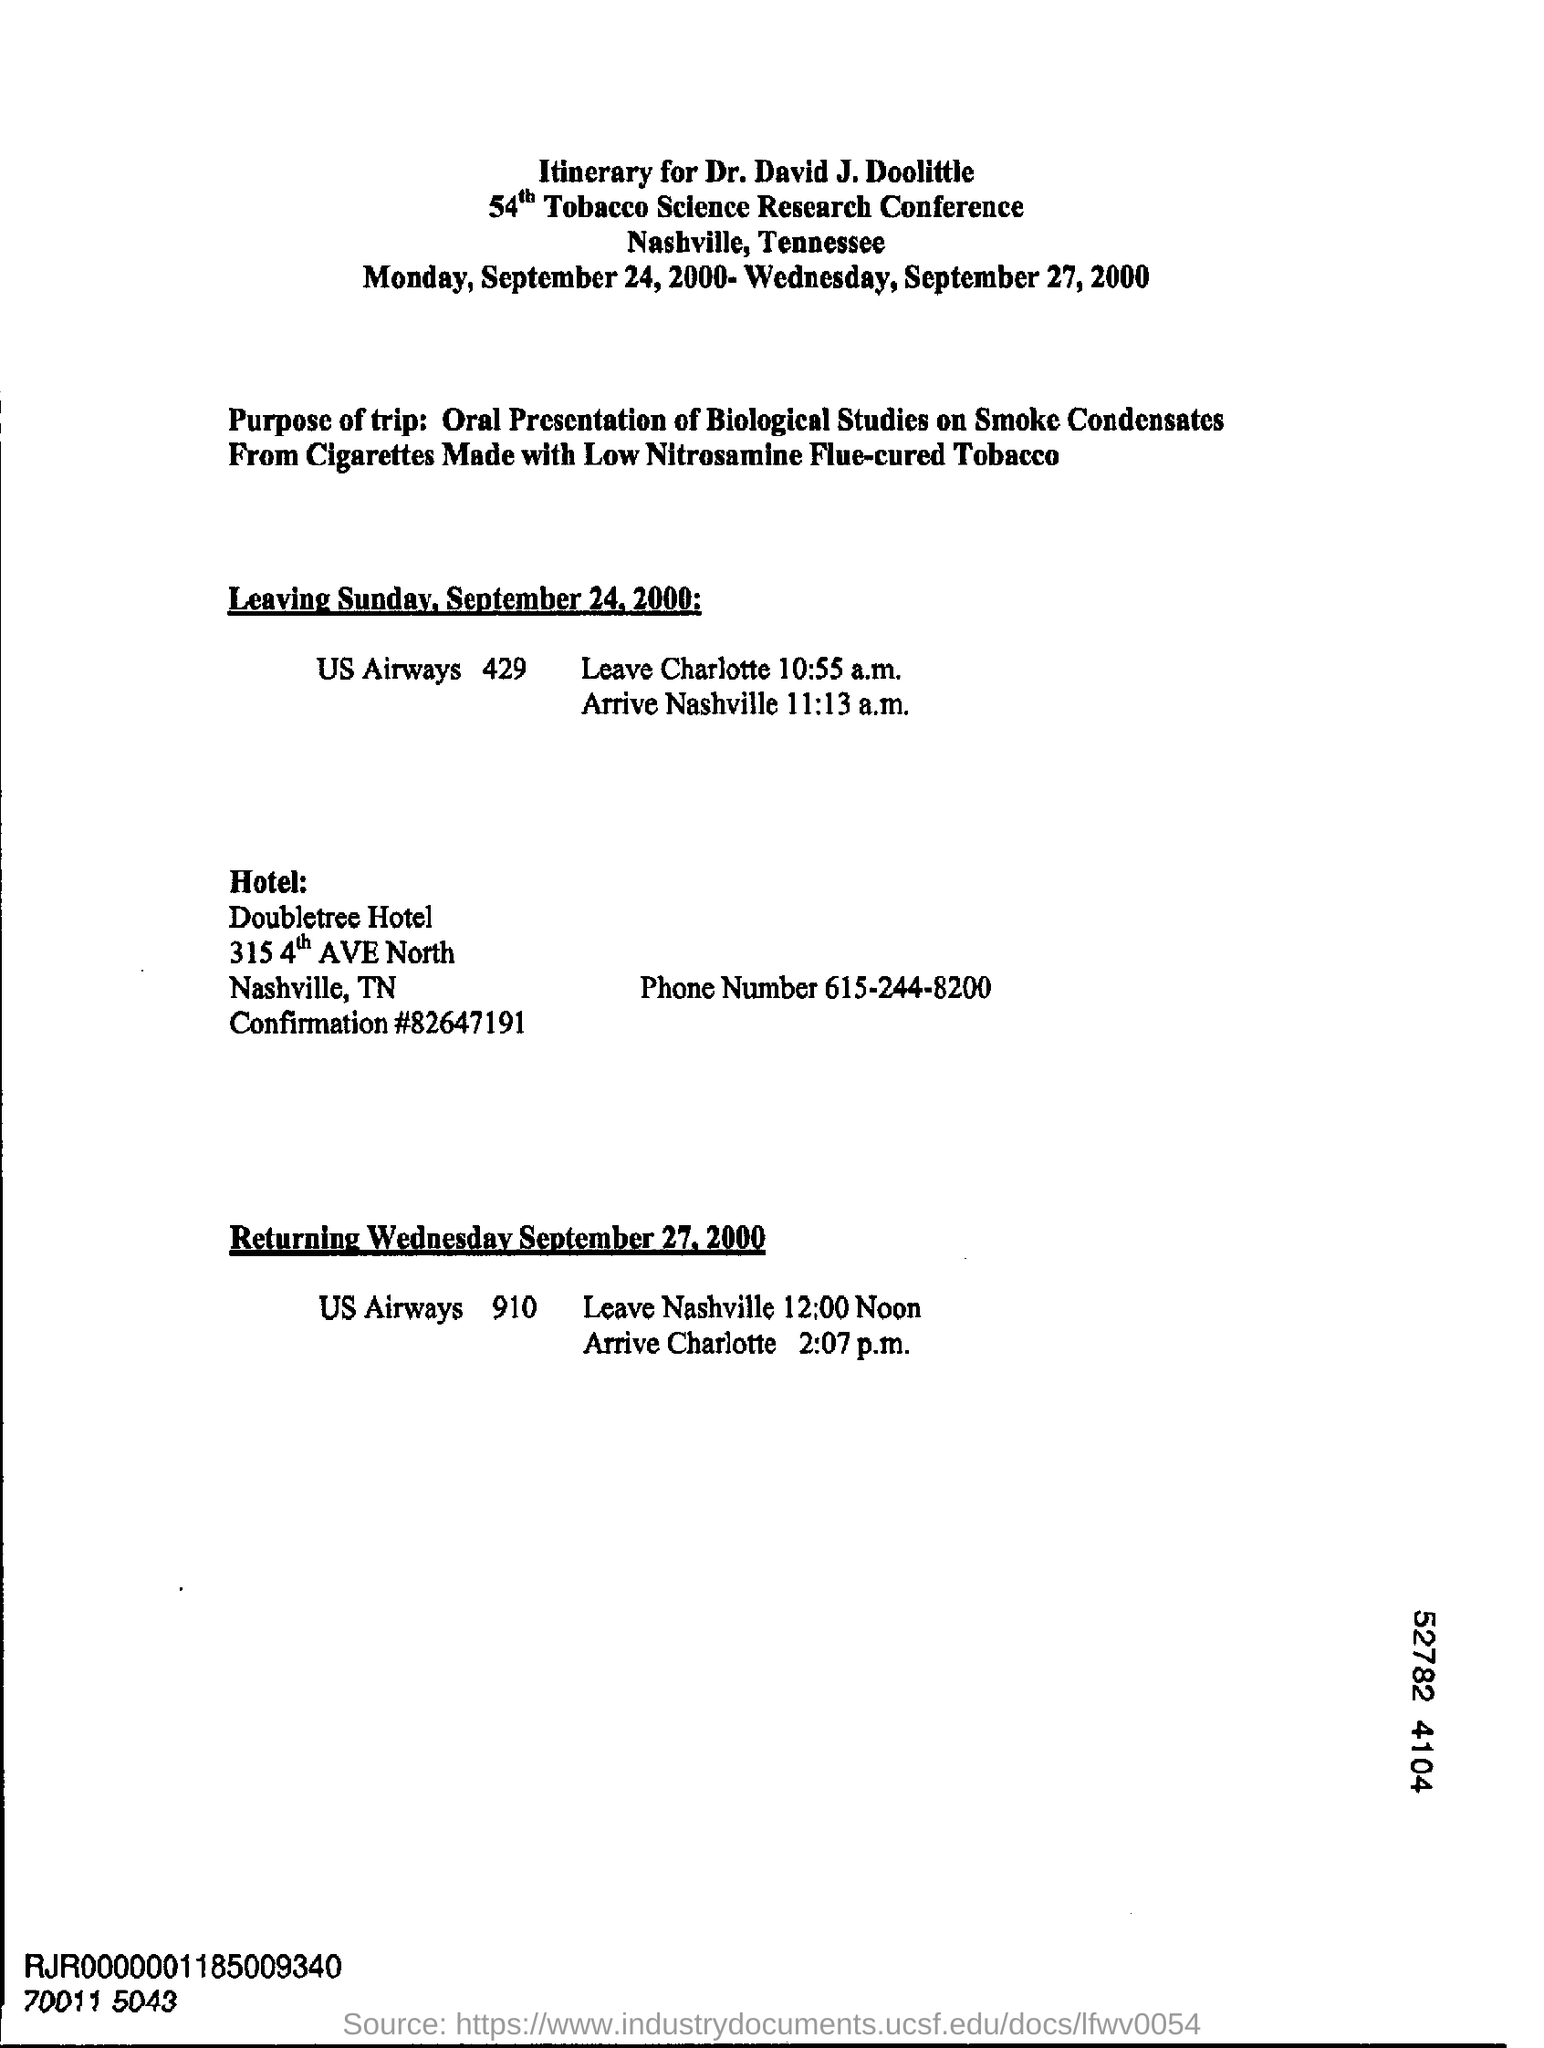What is the phone number of doubletree hotel ?
Your answer should be compact. 615-244-8200. In which state is doubletree hotel at?
Make the answer very short. TN. 